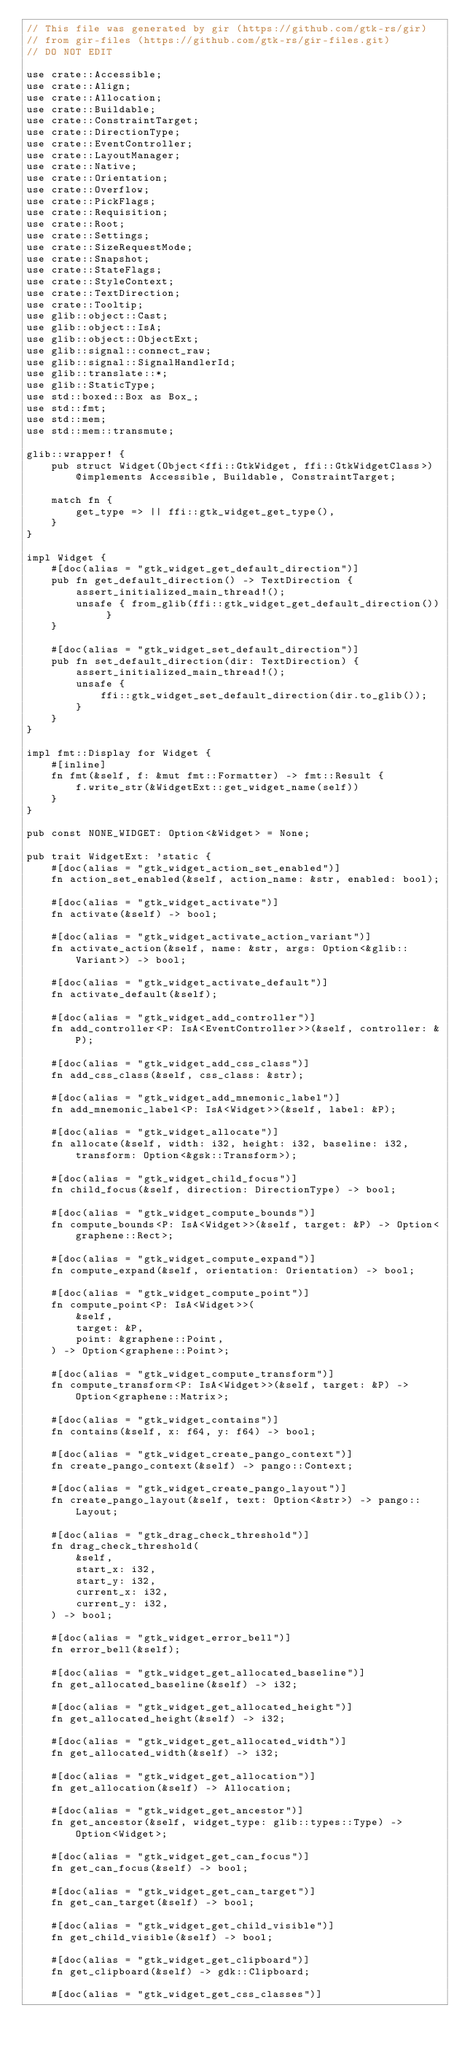<code> <loc_0><loc_0><loc_500><loc_500><_Rust_>// This file was generated by gir (https://github.com/gtk-rs/gir)
// from gir-files (https://github.com/gtk-rs/gir-files.git)
// DO NOT EDIT

use crate::Accessible;
use crate::Align;
use crate::Allocation;
use crate::Buildable;
use crate::ConstraintTarget;
use crate::DirectionType;
use crate::EventController;
use crate::LayoutManager;
use crate::Native;
use crate::Orientation;
use crate::Overflow;
use crate::PickFlags;
use crate::Requisition;
use crate::Root;
use crate::Settings;
use crate::SizeRequestMode;
use crate::Snapshot;
use crate::StateFlags;
use crate::StyleContext;
use crate::TextDirection;
use crate::Tooltip;
use glib::object::Cast;
use glib::object::IsA;
use glib::object::ObjectExt;
use glib::signal::connect_raw;
use glib::signal::SignalHandlerId;
use glib::translate::*;
use glib::StaticType;
use std::boxed::Box as Box_;
use std::fmt;
use std::mem;
use std::mem::transmute;

glib::wrapper! {
    pub struct Widget(Object<ffi::GtkWidget, ffi::GtkWidgetClass>) @implements Accessible, Buildable, ConstraintTarget;

    match fn {
        get_type => || ffi::gtk_widget_get_type(),
    }
}

impl Widget {
    #[doc(alias = "gtk_widget_get_default_direction")]
    pub fn get_default_direction() -> TextDirection {
        assert_initialized_main_thread!();
        unsafe { from_glib(ffi::gtk_widget_get_default_direction()) }
    }

    #[doc(alias = "gtk_widget_set_default_direction")]
    pub fn set_default_direction(dir: TextDirection) {
        assert_initialized_main_thread!();
        unsafe {
            ffi::gtk_widget_set_default_direction(dir.to_glib());
        }
    }
}

impl fmt::Display for Widget {
    #[inline]
    fn fmt(&self, f: &mut fmt::Formatter) -> fmt::Result {
        f.write_str(&WidgetExt::get_widget_name(self))
    }
}

pub const NONE_WIDGET: Option<&Widget> = None;

pub trait WidgetExt: 'static {
    #[doc(alias = "gtk_widget_action_set_enabled")]
    fn action_set_enabled(&self, action_name: &str, enabled: bool);

    #[doc(alias = "gtk_widget_activate")]
    fn activate(&self) -> bool;

    #[doc(alias = "gtk_widget_activate_action_variant")]
    fn activate_action(&self, name: &str, args: Option<&glib::Variant>) -> bool;

    #[doc(alias = "gtk_widget_activate_default")]
    fn activate_default(&self);

    #[doc(alias = "gtk_widget_add_controller")]
    fn add_controller<P: IsA<EventController>>(&self, controller: &P);

    #[doc(alias = "gtk_widget_add_css_class")]
    fn add_css_class(&self, css_class: &str);

    #[doc(alias = "gtk_widget_add_mnemonic_label")]
    fn add_mnemonic_label<P: IsA<Widget>>(&self, label: &P);

    #[doc(alias = "gtk_widget_allocate")]
    fn allocate(&self, width: i32, height: i32, baseline: i32, transform: Option<&gsk::Transform>);

    #[doc(alias = "gtk_widget_child_focus")]
    fn child_focus(&self, direction: DirectionType) -> bool;

    #[doc(alias = "gtk_widget_compute_bounds")]
    fn compute_bounds<P: IsA<Widget>>(&self, target: &P) -> Option<graphene::Rect>;

    #[doc(alias = "gtk_widget_compute_expand")]
    fn compute_expand(&self, orientation: Orientation) -> bool;

    #[doc(alias = "gtk_widget_compute_point")]
    fn compute_point<P: IsA<Widget>>(
        &self,
        target: &P,
        point: &graphene::Point,
    ) -> Option<graphene::Point>;

    #[doc(alias = "gtk_widget_compute_transform")]
    fn compute_transform<P: IsA<Widget>>(&self, target: &P) -> Option<graphene::Matrix>;

    #[doc(alias = "gtk_widget_contains")]
    fn contains(&self, x: f64, y: f64) -> bool;

    #[doc(alias = "gtk_widget_create_pango_context")]
    fn create_pango_context(&self) -> pango::Context;

    #[doc(alias = "gtk_widget_create_pango_layout")]
    fn create_pango_layout(&self, text: Option<&str>) -> pango::Layout;

    #[doc(alias = "gtk_drag_check_threshold")]
    fn drag_check_threshold(
        &self,
        start_x: i32,
        start_y: i32,
        current_x: i32,
        current_y: i32,
    ) -> bool;

    #[doc(alias = "gtk_widget_error_bell")]
    fn error_bell(&self);

    #[doc(alias = "gtk_widget_get_allocated_baseline")]
    fn get_allocated_baseline(&self) -> i32;

    #[doc(alias = "gtk_widget_get_allocated_height")]
    fn get_allocated_height(&self) -> i32;

    #[doc(alias = "gtk_widget_get_allocated_width")]
    fn get_allocated_width(&self) -> i32;

    #[doc(alias = "gtk_widget_get_allocation")]
    fn get_allocation(&self) -> Allocation;

    #[doc(alias = "gtk_widget_get_ancestor")]
    fn get_ancestor(&self, widget_type: glib::types::Type) -> Option<Widget>;

    #[doc(alias = "gtk_widget_get_can_focus")]
    fn get_can_focus(&self) -> bool;

    #[doc(alias = "gtk_widget_get_can_target")]
    fn get_can_target(&self) -> bool;

    #[doc(alias = "gtk_widget_get_child_visible")]
    fn get_child_visible(&self) -> bool;

    #[doc(alias = "gtk_widget_get_clipboard")]
    fn get_clipboard(&self) -> gdk::Clipboard;

    #[doc(alias = "gtk_widget_get_css_classes")]</code> 